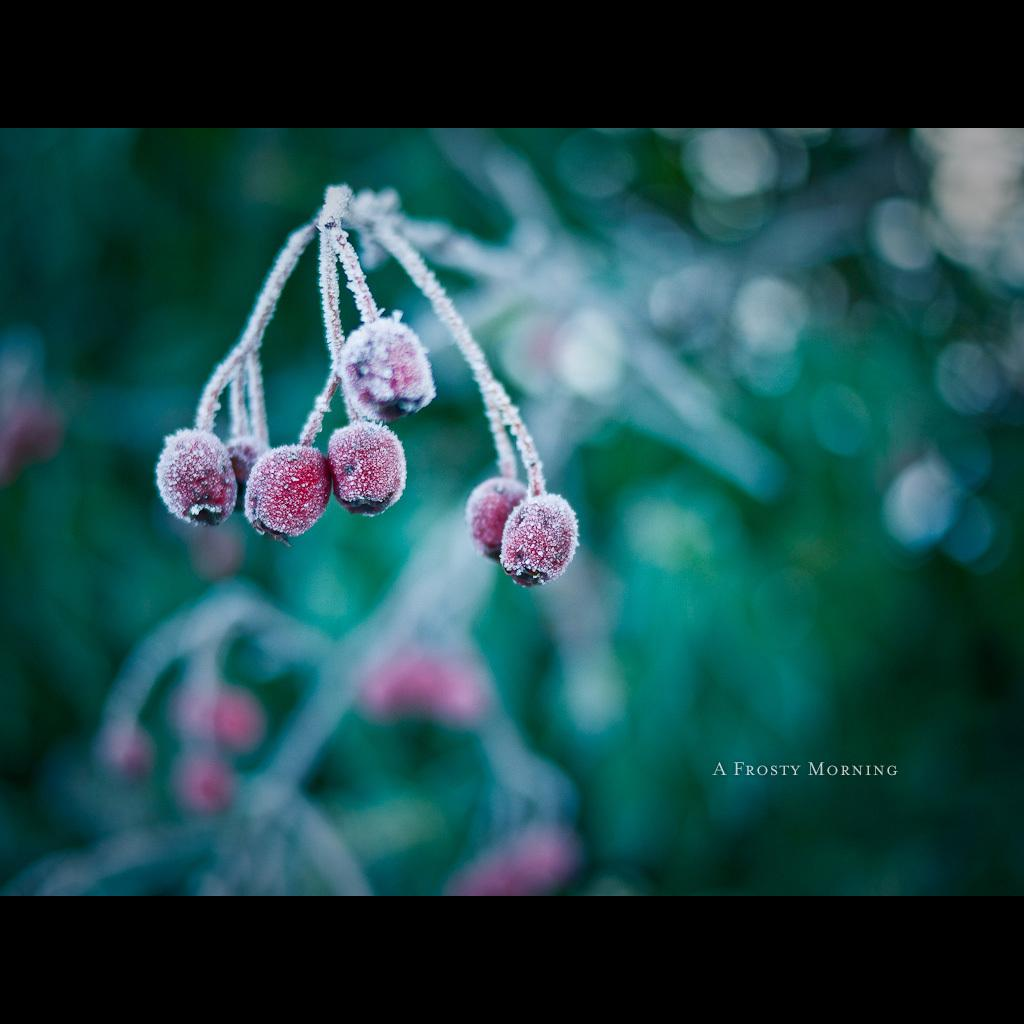What type of food can be seen in the image? There are fruits in the image. What part of the fruit is visible in the image? There is a green stem in the image. How would you describe the background of the image? The background of the image is blurred. What type of owl can be seen in the image? There is no owl present in the image; it features fruits and a green stem. Can you tell me how the fruits are organized in the image? The provided facts do not mention any specific organization of the fruits in the image. 